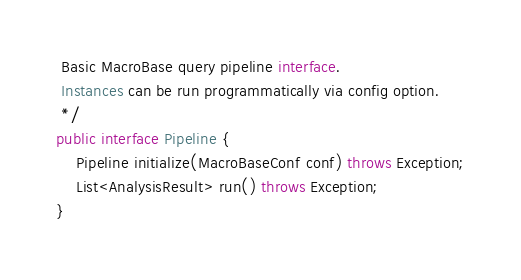Convert code to text. <code><loc_0><loc_0><loc_500><loc_500><_Java_> Basic MacroBase query pipeline interface.
 Instances can be run programmatically via config option.
 */
public interface Pipeline {
    Pipeline initialize(MacroBaseConf conf) throws Exception;
    List<AnalysisResult> run() throws Exception;
}</code> 